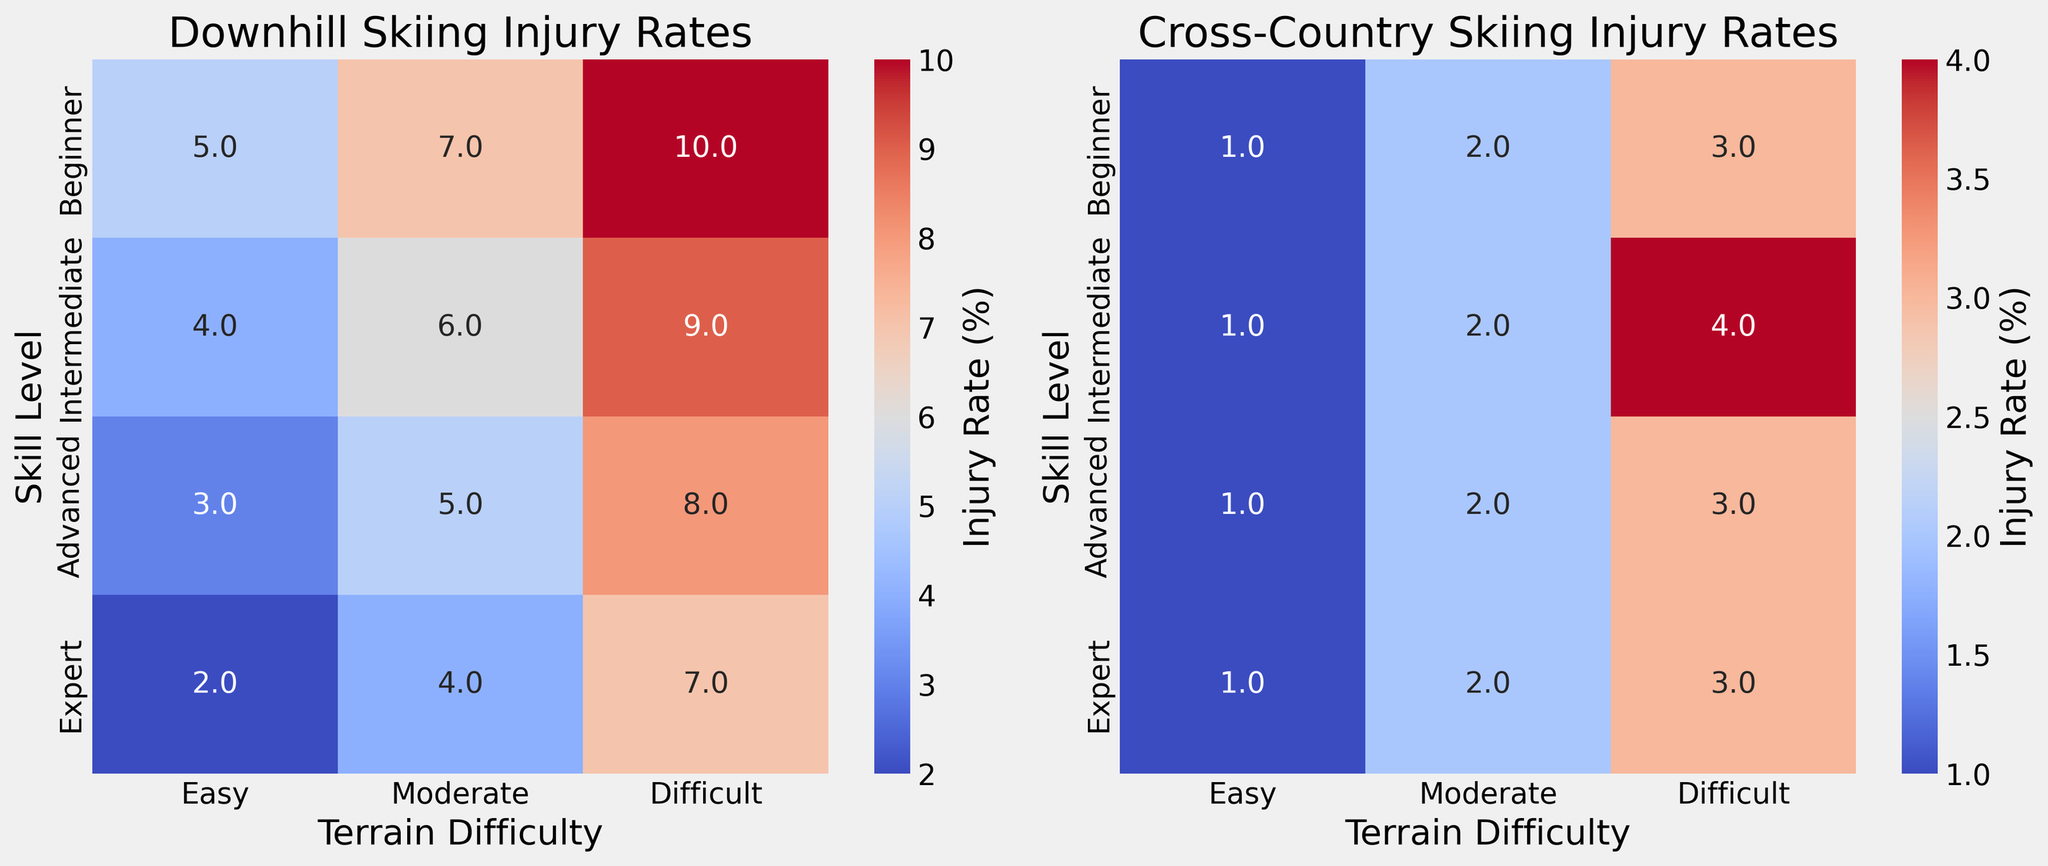What is the injury rate for Beginners on Difficult terrain in Downhill skiing? Look at the cell corresponding to "Beginner" skill level and "Difficult" terrain in the Downhill skiing heatmap. It shows an injury rate percentage.
Answer: 10% Which skill level has the highest injury rate on Easy terrain in Cross-Country skiing? Compare the injury rates across all skill levels on Easy terrain in the Cross-Country skiing heatmap to see which one has the highest value.
Answer: All skill levels have an equal rate of 1% How much higher is the injury rate for Experts on Moderate terrain compared to Beginners on the same terrain in Downhill skiing? Find the injury rates for Experts and Beginners on Moderate terrain in the Downhill skiing heatmap. Subtract the Beginners’ injury rate from the Experts’ injury rate.
Answer: 4 - 7 = -3% What is the average injury rate for Intermediate skiers across all terrain difficulties in Cross-Country skiing? Find the injury rates for Intermediate skiers in Cross-Country skiing for all terrain difficulties (Easy, Moderate, Difficult), sum them up, and divide by the number of terrain difficulties (3).
Answer: Average = (1 + 2 + 4) / 3 = 2.33% Which terrain difficulty shows the most significant difference in injury rates between Advanced and Expert skiers in Downhill skiing? Calculate the differences in injury rates between Advanced and Expert skiers for each terrain difficulty (Easy, Moderate, Difficult) in Downhill skiing and observe which has the highest difference.
Answer: Moderate (1% difference) Which skill level generally has the lowest injury rates across all terrains in Cross-Country skiing? Look at the Cross-Country skiing heatmap and compare the injury rates across all skill levels. Identify the skill level that consistently has the lowest values across terrains.
Answer: Expert When comparing terrain difficulties in Cross-Country skiing, which difficulty level generally has the lowest injury rates for Advanced skiers? Check the Cross-Country skiing heatmap for Advanced skiers and compare injury rates across Easy, Moderate, and Difficult terrains. Identify the one with the lowest value.
Answer: Easy What is the total injury rate for all skill levels combined on Difficult terrain in Downhill skiing? Find the injury rates for all skill levels on Difficult terrain in Downhill skiing, and sum them up.
Answer: Total = 10 + 9 + 8 + 7 = 34% How does the injury rate for Intermediate skiers on Moderate terrain in Cross-Country skiing compare visually to the same terrain in Downhill skiing? Look for visual differences (color intensity) between the cells corresponding to Intermediate skiers on Moderate terrain in Downhill and Cross-Country skiing.
Answer: Downhill is darker indicating higher rates 